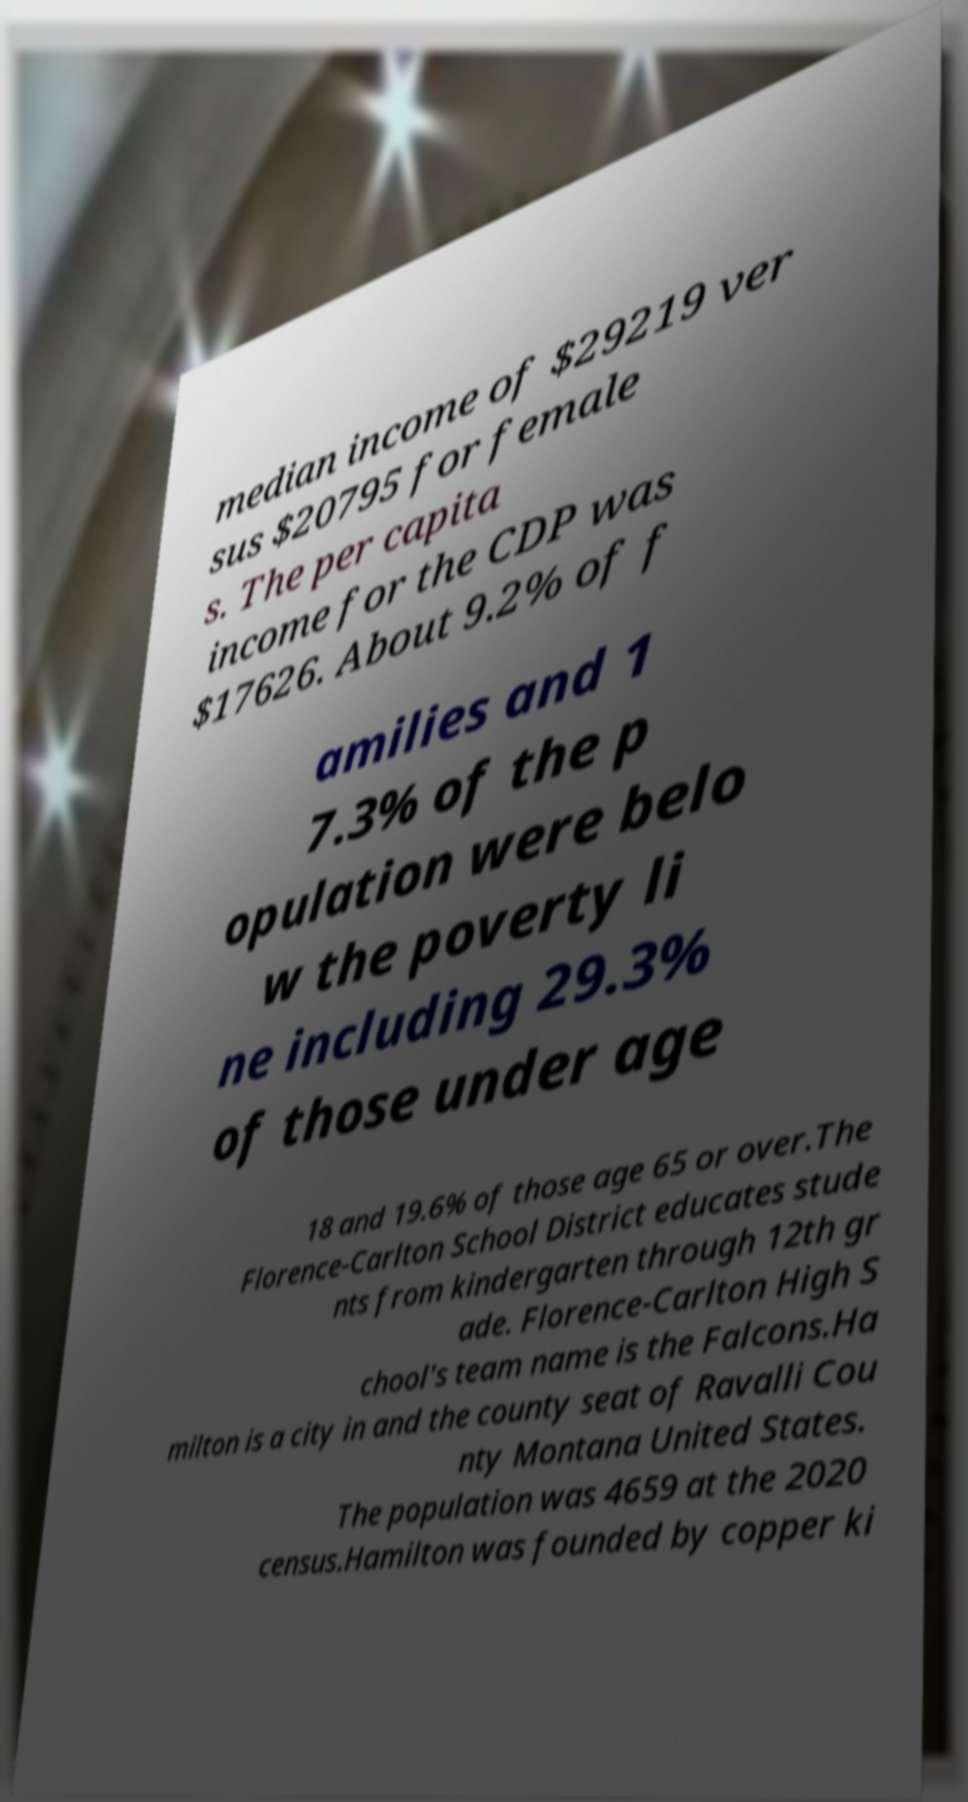Could you extract and type out the text from this image? median income of $29219 ver sus $20795 for female s. The per capita income for the CDP was $17626. About 9.2% of f amilies and 1 7.3% of the p opulation were belo w the poverty li ne including 29.3% of those under age 18 and 19.6% of those age 65 or over.The Florence-Carlton School District educates stude nts from kindergarten through 12th gr ade. Florence-Carlton High S chool's team name is the Falcons.Ha milton is a city in and the county seat of Ravalli Cou nty Montana United States. The population was 4659 at the 2020 census.Hamilton was founded by copper ki 